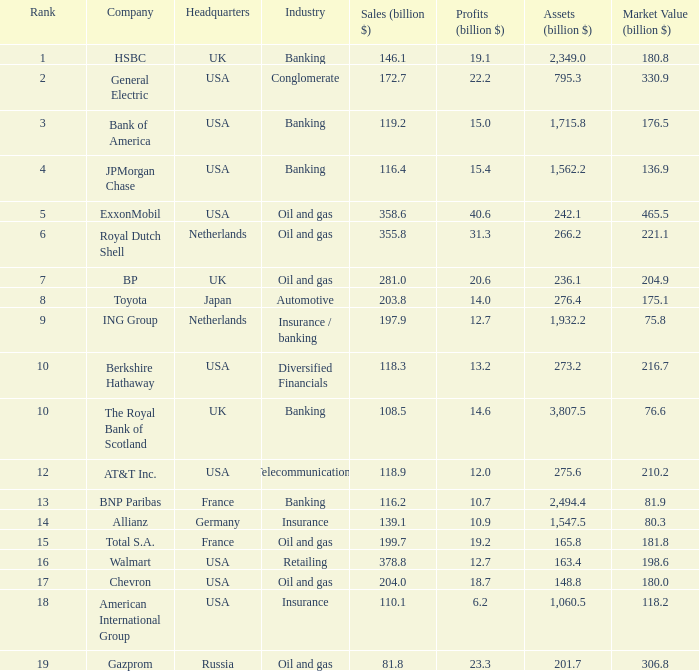What is the highest rank of a company that has 1,715.8 billion in assets?  3.0. 